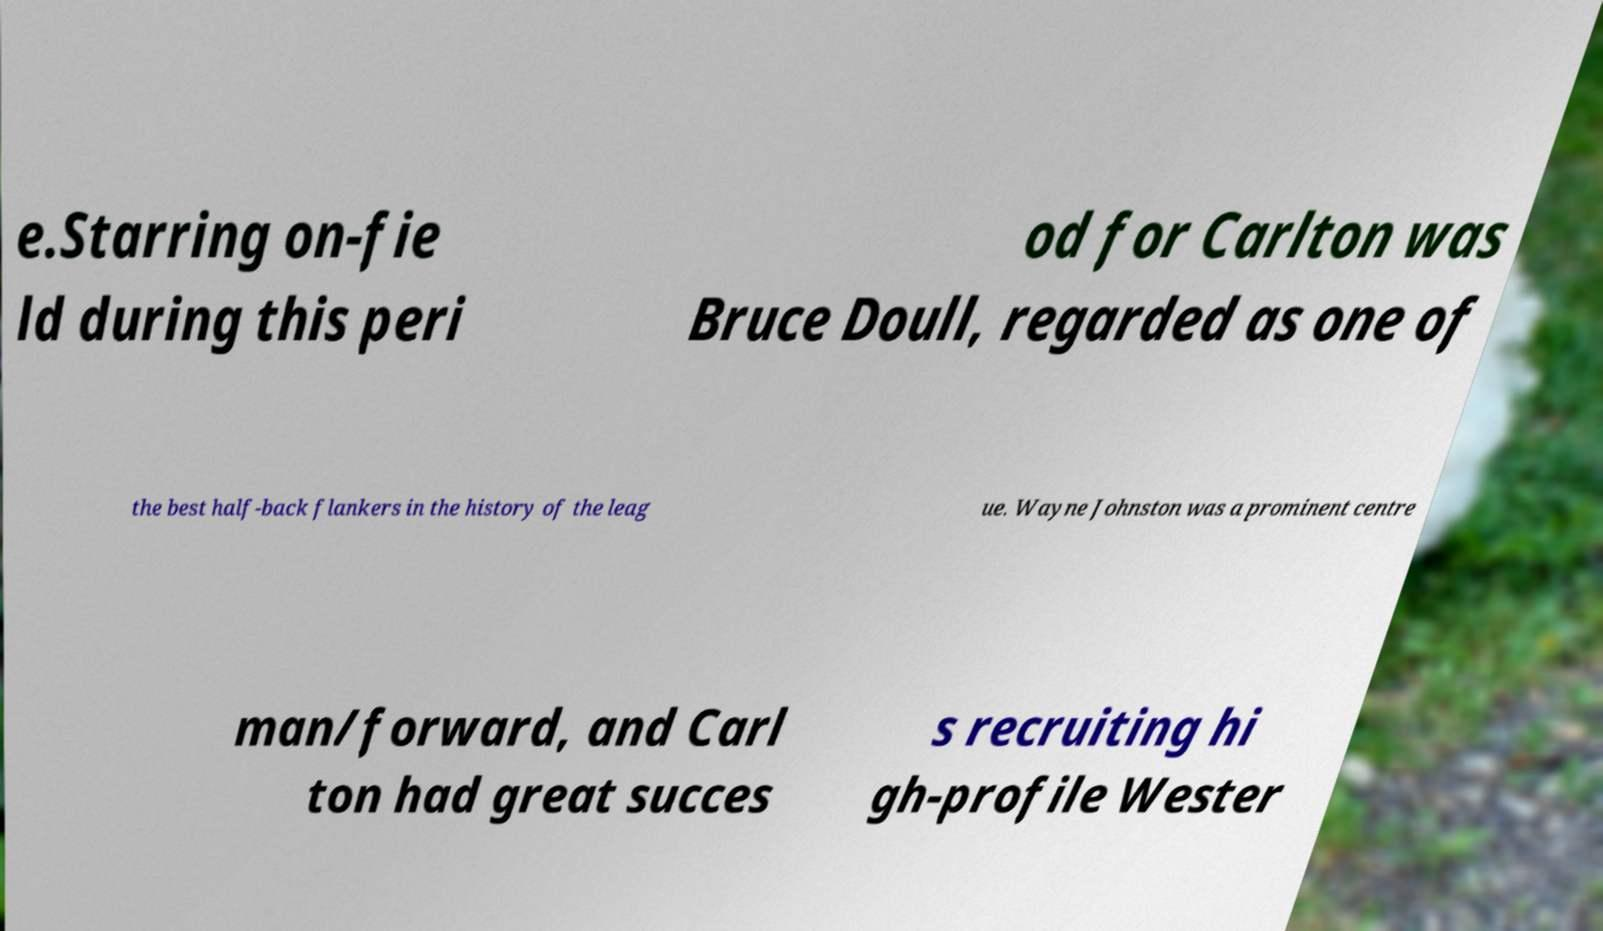Please identify and transcribe the text found in this image. e.Starring on-fie ld during this peri od for Carlton was Bruce Doull, regarded as one of the best half-back flankers in the history of the leag ue. Wayne Johnston was a prominent centre man/forward, and Carl ton had great succes s recruiting hi gh-profile Wester 